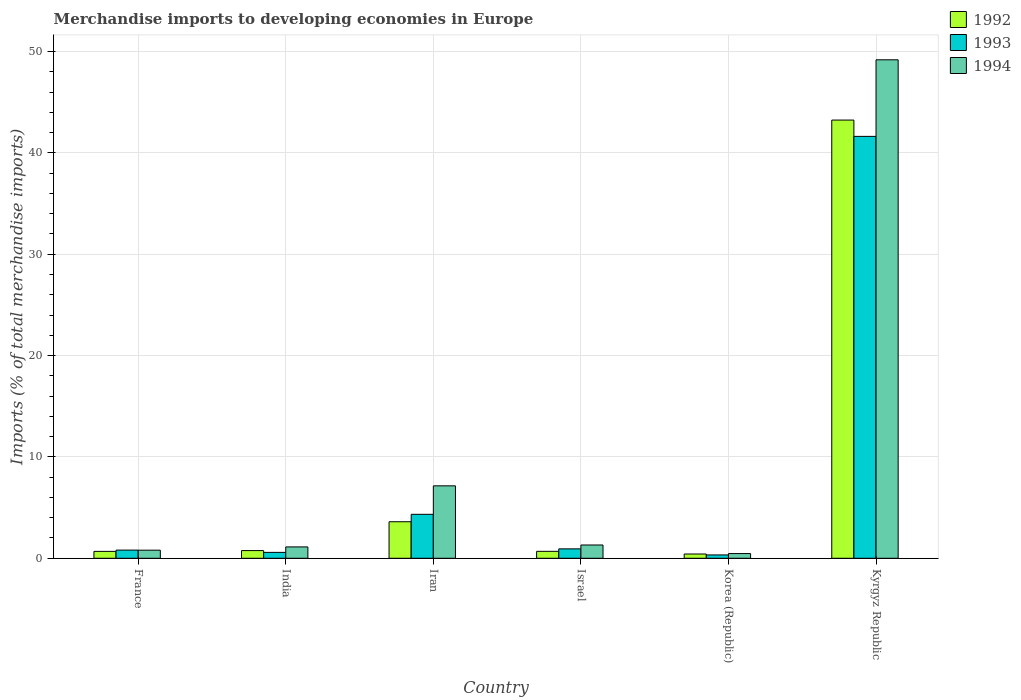How many groups of bars are there?
Offer a terse response. 6. Are the number of bars per tick equal to the number of legend labels?
Offer a very short reply. Yes. What is the label of the 3rd group of bars from the left?
Make the answer very short. Iran. In how many cases, is the number of bars for a given country not equal to the number of legend labels?
Provide a succinct answer. 0. What is the percentage total merchandise imports in 1994 in France?
Your answer should be compact. 0.8. Across all countries, what is the maximum percentage total merchandise imports in 1992?
Offer a terse response. 43.24. Across all countries, what is the minimum percentage total merchandise imports in 1993?
Provide a succinct answer. 0.33. In which country was the percentage total merchandise imports in 1992 maximum?
Offer a very short reply. Kyrgyz Republic. In which country was the percentage total merchandise imports in 1994 minimum?
Your answer should be very brief. Korea (Republic). What is the total percentage total merchandise imports in 1994 in the graph?
Offer a terse response. 60.02. What is the difference between the percentage total merchandise imports in 1994 in France and that in India?
Offer a very short reply. -0.32. What is the difference between the percentage total merchandise imports in 1992 in India and the percentage total merchandise imports in 1994 in Israel?
Provide a succinct answer. -0.55. What is the average percentage total merchandise imports in 1992 per country?
Your answer should be compact. 8.23. What is the difference between the percentage total merchandise imports of/in 1992 and percentage total merchandise imports of/in 1993 in Korea (Republic)?
Keep it short and to the point. 0.09. What is the ratio of the percentage total merchandise imports in 1992 in India to that in Israel?
Provide a short and direct response. 1.11. Is the percentage total merchandise imports in 1992 in France less than that in Israel?
Offer a terse response. Yes. Is the difference between the percentage total merchandise imports in 1992 in Israel and Kyrgyz Republic greater than the difference between the percentage total merchandise imports in 1993 in Israel and Kyrgyz Republic?
Offer a very short reply. No. What is the difference between the highest and the second highest percentage total merchandise imports in 1993?
Make the answer very short. -40.7. What is the difference between the highest and the lowest percentage total merchandise imports in 1992?
Your answer should be very brief. 42.82. In how many countries, is the percentage total merchandise imports in 1992 greater than the average percentage total merchandise imports in 1992 taken over all countries?
Ensure brevity in your answer.  1. What does the 2nd bar from the left in Iran represents?
Your response must be concise. 1993. How many bars are there?
Your response must be concise. 18. What is the difference between two consecutive major ticks on the Y-axis?
Provide a short and direct response. 10. Does the graph contain any zero values?
Ensure brevity in your answer.  No. Where does the legend appear in the graph?
Make the answer very short. Top right. What is the title of the graph?
Offer a very short reply. Merchandise imports to developing economies in Europe. What is the label or title of the Y-axis?
Offer a very short reply. Imports (% of total merchandise imports). What is the Imports (% of total merchandise imports) of 1992 in France?
Offer a terse response. 0.68. What is the Imports (% of total merchandise imports) in 1993 in France?
Offer a very short reply. 0.81. What is the Imports (% of total merchandise imports) of 1994 in France?
Your response must be concise. 0.8. What is the Imports (% of total merchandise imports) of 1992 in India?
Your answer should be very brief. 0.76. What is the Imports (% of total merchandise imports) in 1993 in India?
Provide a short and direct response. 0.58. What is the Imports (% of total merchandise imports) of 1994 in India?
Your response must be concise. 1.12. What is the Imports (% of total merchandise imports) of 1992 in Iran?
Offer a terse response. 3.6. What is the Imports (% of total merchandise imports) of 1993 in Iran?
Your answer should be compact. 4.34. What is the Imports (% of total merchandise imports) of 1994 in Iran?
Offer a very short reply. 7.15. What is the Imports (% of total merchandise imports) of 1992 in Israel?
Give a very brief answer. 0.68. What is the Imports (% of total merchandise imports) of 1993 in Israel?
Ensure brevity in your answer.  0.93. What is the Imports (% of total merchandise imports) of 1994 in Israel?
Make the answer very short. 1.31. What is the Imports (% of total merchandise imports) in 1992 in Korea (Republic)?
Offer a terse response. 0.42. What is the Imports (% of total merchandise imports) of 1993 in Korea (Republic)?
Ensure brevity in your answer.  0.33. What is the Imports (% of total merchandise imports) of 1994 in Korea (Republic)?
Offer a terse response. 0.46. What is the Imports (% of total merchandise imports) in 1992 in Kyrgyz Republic?
Give a very brief answer. 43.24. What is the Imports (% of total merchandise imports) of 1993 in Kyrgyz Republic?
Ensure brevity in your answer.  41.63. What is the Imports (% of total merchandise imports) of 1994 in Kyrgyz Republic?
Keep it short and to the point. 49.18. Across all countries, what is the maximum Imports (% of total merchandise imports) in 1992?
Provide a succinct answer. 43.24. Across all countries, what is the maximum Imports (% of total merchandise imports) of 1993?
Provide a succinct answer. 41.63. Across all countries, what is the maximum Imports (% of total merchandise imports) of 1994?
Provide a short and direct response. 49.18. Across all countries, what is the minimum Imports (% of total merchandise imports) of 1992?
Your answer should be very brief. 0.42. Across all countries, what is the minimum Imports (% of total merchandise imports) of 1993?
Your answer should be very brief. 0.33. Across all countries, what is the minimum Imports (% of total merchandise imports) of 1994?
Your answer should be compact. 0.46. What is the total Imports (% of total merchandise imports) of 1992 in the graph?
Keep it short and to the point. 49.38. What is the total Imports (% of total merchandise imports) in 1993 in the graph?
Offer a very short reply. 48.61. What is the total Imports (% of total merchandise imports) in 1994 in the graph?
Keep it short and to the point. 60.02. What is the difference between the Imports (% of total merchandise imports) in 1992 in France and that in India?
Offer a terse response. -0.08. What is the difference between the Imports (% of total merchandise imports) in 1993 in France and that in India?
Your answer should be compact. 0.22. What is the difference between the Imports (% of total merchandise imports) of 1994 in France and that in India?
Ensure brevity in your answer.  -0.32. What is the difference between the Imports (% of total merchandise imports) in 1992 in France and that in Iran?
Ensure brevity in your answer.  -2.92. What is the difference between the Imports (% of total merchandise imports) of 1993 in France and that in Iran?
Provide a short and direct response. -3.53. What is the difference between the Imports (% of total merchandise imports) in 1994 in France and that in Iran?
Your response must be concise. -6.35. What is the difference between the Imports (% of total merchandise imports) in 1992 in France and that in Israel?
Offer a very short reply. -0. What is the difference between the Imports (% of total merchandise imports) in 1993 in France and that in Israel?
Make the answer very short. -0.12. What is the difference between the Imports (% of total merchandise imports) in 1994 in France and that in Israel?
Your response must be concise. -0.51. What is the difference between the Imports (% of total merchandise imports) in 1992 in France and that in Korea (Republic)?
Provide a short and direct response. 0.26. What is the difference between the Imports (% of total merchandise imports) in 1993 in France and that in Korea (Republic)?
Your response must be concise. 0.48. What is the difference between the Imports (% of total merchandise imports) in 1994 in France and that in Korea (Republic)?
Ensure brevity in your answer.  0.34. What is the difference between the Imports (% of total merchandise imports) of 1992 in France and that in Kyrgyz Republic?
Offer a terse response. -42.56. What is the difference between the Imports (% of total merchandise imports) in 1993 in France and that in Kyrgyz Republic?
Make the answer very short. -40.82. What is the difference between the Imports (% of total merchandise imports) of 1994 in France and that in Kyrgyz Republic?
Your answer should be very brief. -48.38. What is the difference between the Imports (% of total merchandise imports) of 1992 in India and that in Iran?
Your answer should be compact. -2.84. What is the difference between the Imports (% of total merchandise imports) of 1993 in India and that in Iran?
Offer a terse response. -3.75. What is the difference between the Imports (% of total merchandise imports) of 1994 in India and that in Iran?
Keep it short and to the point. -6.03. What is the difference between the Imports (% of total merchandise imports) of 1992 in India and that in Israel?
Keep it short and to the point. 0.07. What is the difference between the Imports (% of total merchandise imports) in 1993 in India and that in Israel?
Give a very brief answer. -0.35. What is the difference between the Imports (% of total merchandise imports) of 1994 in India and that in Israel?
Your answer should be compact. -0.19. What is the difference between the Imports (% of total merchandise imports) in 1992 in India and that in Korea (Republic)?
Ensure brevity in your answer.  0.34. What is the difference between the Imports (% of total merchandise imports) of 1993 in India and that in Korea (Republic)?
Make the answer very short. 0.25. What is the difference between the Imports (% of total merchandise imports) of 1994 in India and that in Korea (Republic)?
Make the answer very short. 0.66. What is the difference between the Imports (% of total merchandise imports) in 1992 in India and that in Kyrgyz Republic?
Your response must be concise. -42.48. What is the difference between the Imports (% of total merchandise imports) in 1993 in India and that in Kyrgyz Republic?
Keep it short and to the point. -41.05. What is the difference between the Imports (% of total merchandise imports) of 1994 in India and that in Kyrgyz Republic?
Your answer should be compact. -48.06. What is the difference between the Imports (% of total merchandise imports) in 1992 in Iran and that in Israel?
Provide a short and direct response. 2.92. What is the difference between the Imports (% of total merchandise imports) of 1993 in Iran and that in Israel?
Offer a very short reply. 3.41. What is the difference between the Imports (% of total merchandise imports) in 1994 in Iran and that in Israel?
Provide a short and direct response. 5.84. What is the difference between the Imports (% of total merchandise imports) of 1992 in Iran and that in Korea (Republic)?
Ensure brevity in your answer.  3.18. What is the difference between the Imports (% of total merchandise imports) of 1993 in Iran and that in Korea (Republic)?
Your answer should be compact. 4.01. What is the difference between the Imports (% of total merchandise imports) of 1994 in Iran and that in Korea (Republic)?
Your response must be concise. 6.68. What is the difference between the Imports (% of total merchandise imports) in 1992 in Iran and that in Kyrgyz Republic?
Keep it short and to the point. -39.63. What is the difference between the Imports (% of total merchandise imports) in 1993 in Iran and that in Kyrgyz Republic?
Offer a terse response. -37.29. What is the difference between the Imports (% of total merchandise imports) in 1994 in Iran and that in Kyrgyz Republic?
Your response must be concise. -42.04. What is the difference between the Imports (% of total merchandise imports) in 1992 in Israel and that in Korea (Republic)?
Provide a short and direct response. 0.26. What is the difference between the Imports (% of total merchandise imports) in 1993 in Israel and that in Korea (Republic)?
Your response must be concise. 0.6. What is the difference between the Imports (% of total merchandise imports) in 1994 in Israel and that in Korea (Republic)?
Keep it short and to the point. 0.85. What is the difference between the Imports (% of total merchandise imports) in 1992 in Israel and that in Kyrgyz Republic?
Provide a succinct answer. -42.55. What is the difference between the Imports (% of total merchandise imports) in 1993 in Israel and that in Kyrgyz Republic?
Make the answer very short. -40.7. What is the difference between the Imports (% of total merchandise imports) in 1994 in Israel and that in Kyrgyz Republic?
Your response must be concise. -47.87. What is the difference between the Imports (% of total merchandise imports) of 1992 in Korea (Republic) and that in Kyrgyz Republic?
Ensure brevity in your answer.  -42.82. What is the difference between the Imports (% of total merchandise imports) of 1993 in Korea (Republic) and that in Kyrgyz Republic?
Offer a very short reply. -41.3. What is the difference between the Imports (% of total merchandise imports) of 1994 in Korea (Republic) and that in Kyrgyz Republic?
Ensure brevity in your answer.  -48.72. What is the difference between the Imports (% of total merchandise imports) of 1992 in France and the Imports (% of total merchandise imports) of 1993 in India?
Keep it short and to the point. 0.1. What is the difference between the Imports (% of total merchandise imports) in 1992 in France and the Imports (% of total merchandise imports) in 1994 in India?
Make the answer very short. -0.44. What is the difference between the Imports (% of total merchandise imports) in 1993 in France and the Imports (% of total merchandise imports) in 1994 in India?
Make the answer very short. -0.31. What is the difference between the Imports (% of total merchandise imports) of 1992 in France and the Imports (% of total merchandise imports) of 1993 in Iran?
Your answer should be compact. -3.66. What is the difference between the Imports (% of total merchandise imports) in 1992 in France and the Imports (% of total merchandise imports) in 1994 in Iran?
Make the answer very short. -6.47. What is the difference between the Imports (% of total merchandise imports) in 1993 in France and the Imports (% of total merchandise imports) in 1994 in Iran?
Give a very brief answer. -6.34. What is the difference between the Imports (% of total merchandise imports) of 1992 in France and the Imports (% of total merchandise imports) of 1993 in Israel?
Provide a short and direct response. -0.25. What is the difference between the Imports (% of total merchandise imports) in 1992 in France and the Imports (% of total merchandise imports) in 1994 in Israel?
Provide a succinct answer. -0.63. What is the difference between the Imports (% of total merchandise imports) of 1993 in France and the Imports (% of total merchandise imports) of 1994 in Israel?
Provide a succinct answer. -0.5. What is the difference between the Imports (% of total merchandise imports) of 1992 in France and the Imports (% of total merchandise imports) of 1993 in Korea (Republic)?
Offer a terse response. 0.35. What is the difference between the Imports (% of total merchandise imports) in 1992 in France and the Imports (% of total merchandise imports) in 1994 in Korea (Republic)?
Your response must be concise. 0.22. What is the difference between the Imports (% of total merchandise imports) in 1993 in France and the Imports (% of total merchandise imports) in 1994 in Korea (Republic)?
Your response must be concise. 0.34. What is the difference between the Imports (% of total merchandise imports) in 1992 in France and the Imports (% of total merchandise imports) in 1993 in Kyrgyz Republic?
Your response must be concise. -40.95. What is the difference between the Imports (% of total merchandise imports) of 1992 in France and the Imports (% of total merchandise imports) of 1994 in Kyrgyz Republic?
Provide a short and direct response. -48.5. What is the difference between the Imports (% of total merchandise imports) of 1993 in France and the Imports (% of total merchandise imports) of 1994 in Kyrgyz Republic?
Ensure brevity in your answer.  -48.38. What is the difference between the Imports (% of total merchandise imports) in 1992 in India and the Imports (% of total merchandise imports) in 1993 in Iran?
Provide a short and direct response. -3.58. What is the difference between the Imports (% of total merchandise imports) of 1992 in India and the Imports (% of total merchandise imports) of 1994 in Iran?
Ensure brevity in your answer.  -6.39. What is the difference between the Imports (% of total merchandise imports) of 1993 in India and the Imports (% of total merchandise imports) of 1994 in Iran?
Keep it short and to the point. -6.57. What is the difference between the Imports (% of total merchandise imports) of 1992 in India and the Imports (% of total merchandise imports) of 1993 in Israel?
Make the answer very short. -0.17. What is the difference between the Imports (% of total merchandise imports) in 1992 in India and the Imports (% of total merchandise imports) in 1994 in Israel?
Make the answer very short. -0.55. What is the difference between the Imports (% of total merchandise imports) of 1993 in India and the Imports (% of total merchandise imports) of 1994 in Israel?
Offer a very short reply. -0.73. What is the difference between the Imports (% of total merchandise imports) in 1992 in India and the Imports (% of total merchandise imports) in 1993 in Korea (Republic)?
Offer a terse response. 0.43. What is the difference between the Imports (% of total merchandise imports) in 1992 in India and the Imports (% of total merchandise imports) in 1994 in Korea (Republic)?
Give a very brief answer. 0.3. What is the difference between the Imports (% of total merchandise imports) of 1993 in India and the Imports (% of total merchandise imports) of 1994 in Korea (Republic)?
Ensure brevity in your answer.  0.12. What is the difference between the Imports (% of total merchandise imports) in 1992 in India and the Imports (% of total merchandise imports) in 1993 in Kyrgyz Republic?
Your response must be concise. -40.87. What is the difference between the Imports (% of total merchandise imports) of 1992 in India and the Imports (% of total merchandise imports) of 1994 in Kyrgyz Republic?
Ensure brevity in your answer.  -48.42. What is the difference between the Imports (% of total merchandise imports) of 1993 in India and the Imports (% of total merchandise imports) of 1994 in Kyrgyz Republic?
Your response must be concise. -48.6. What is the difference between the Imports (% of total merchandise imports) in 1992 in Iran and the Imports (% of total merchandise imports) in 1993 in Israel?
Make the answer very short. 2.68. What is the difference between the Imports (% of total merchandise imports) of 1992 in Iran and the Imports (% of total merchandise imports) of 1994 in Israel?
Your answer should be very brief. 2.29. What is the difference between the Imports (% of total merchandise imports) of 1993 in Iran and the Imports (% of total merchandise imports) of 1994 in Israel?
Your answer should be very brief. 3.03. What is the difference between the Imports (% of total merchandise imports) in 1992 in Iran and the Imports (% of total merchandise imports) in 1993 in Korea (Republic)?
Keep it short and to the point. 3.27. What is the difference between the Imports (% of total merchandise imports) in 1992 in Iran and the Imports (% of total merchandise imports) in 1994 in Korea (Republic)?
Offer a very short reply. 3.14. What is the difference between the Imports (% of total merchandise imports) in 1993 in Iran and the Imports (% of total merchandise imports) in 1994 in Korea (Republic)?
Provide a short and direct response. 3.87. What is the difference between the Imports (% of total merchandise imports) of 1992 in Iran and the Imports (% of total merchandise imports) of 1993 in Kyrgyz Republic?
Give a very brief answer. -38.02. What is the difference between the Imports (% of total merchandise imports) in 1992 in Iran and the Imports (% of total merchandise imports) in 1994 in Kyrgyz Republic?
Offer a very short reply. -45.58. What is the difference between the Imports (% of total merchandise imports) of 1993 in Iran and the Imports (% of total merchandise imports) of 1994 in Kyrgyz Republic?
Make the answer very short. -44.85. What is the difference between the Imports (% of total merchandise imports) of 1992 in Israel and the Imports (% of total merchandise imports) of 1993 in Korea (Republic)?
Keep it short and to the point. 0.35. What is the difference between the Imports (% of total merchandise imports) of 1992 in Israel and the Imports (% of total merchandise imports) of 1994 in Korea (Republic)?
Provide a short and direct response. 0.22. What is the difference between the Imports (% of total merchandise imports) of 1993 in Israel and the Imports (% of total merchandise imports) of 1994 in Korea (Republic)?
Make the answer very short. 0.46. What is the difference between the Imports (% of total merchandise imports) in 1992 in Israel and the Imports (% of total merchandise imports) in 1993 in Kyrgyz Republic?
Ensure brevity in your answer.  -40.94. What is the difference between the Imports (% of total merchandise imports) of 1992 in Israel and the Imports (% of total merchandise imports) of 1994 in Kyrgyz Republic?
Ensure brevity in your answer.  -48.5. What is the difference between the Imports (% of total merchandise imports) in 1993 in Israel and the Imports (% of total merchandise imports) in 1994 in Kyrgyz Republic?
Make the answer very short. -48.26. What is the difference between the Imports (% of total merchandise imports) in 1992 in Korea (Republic) and the Imports (% of total merchandise imports) in 1993 in Kyrgyz Republic?
Offer a very short reply. -41.21. What is the difference between the Imports (% of total merchandise imports) of 1992 in Korea (Republic) and the Imports (% of total merchandise imports) of 1994 in Kyrgyz Republic?
Make the answer very short. -48.76. What is the difference between the Imports (% of total merchandise imports) in 1993 in Korea (Republic) and the Imports (% of total merchandise imports) in 1994 in Kyrgyz Republic?
Provide a succinct answer. -48.85. What is the average Imports (% of total merchandise imports) in 1992 per country?
Provide a short and direct response. 8.23. What is the average Imports (% of total merchandise imports) in 1993 per country?
Offer a very short reply. 8.1. What is the average Imports (% of total merchandise imports) of 1994 per country?
Provide a short and direct response. 10. What is the difference between the Imports (% of total merchandise imports) of 1992 and Imports (% of total merchandise imports) of 1993 in France?
Offer a very short reply. -0.13. What is the difference between the Imports (% of total merchandise imports) in 1992 and Imports (% of total merchandise imports) in 1994 in France?
Your answer should be very brief. -0.12. What is the difference between the Imports (% of total merchandise imports) of 1993 and Imports (% of total merchandise imports) of 1994 in France?
Provide a short and direct response. 0.01. What is the difference between the Imports (% of total merchandise imports) of 1992 and Imports (% of total merchandise imports) of 1993 in India?
Give a very brief answer. 0.18. What is the difference between the Imports (% of total merchandise imports) of 1992 and Imports (% of total merchandise imports) of 1994 in India?
Your answer should be very brief. -0.36. What is the difference between the Imports (% of total merchandise imports) in 1993 and Imports (% of total merchandise imports) in 1994 in India?
Your answer should be very brief. -0.54. What is the difference between the Imports (% of total merchandise imports) of 1992 and Imports (% of total merchandise imports) of 1993 in Iran?
Provide a short and direct response. -0.73. What is the difference between the Imports (% of total merchandise imports) of 1992 and Imports (% of total merchandise imports) of 1994 in Iran?
Your answer should be very brief. -3.54. What is the difference between the Imports (% of total merchandise imports) in 1993 and Imports (% of total merchandise imports) in 1994 in Iran?
Provide a short and direct response. -2.81. What is the difference between the Imports (% of total merchandise imports) of 1992 and Imports (% of total merchandise imports) of 1993 in Israel?
Your answer should be very brief. -0.24. What is the difference between the Imports (% of total merchandise imports) in 1992 and Imports (% of total merchandise imports) in 1994 in Israel?
Offer a terse response. -0.62. What is the difference between the Imports (% of total merchandise imports) in 1993 and Imports (% of total merchandise imports) in 1994 in Israel?
Ensure brevity in your answer.  -0.38. What is the difference between the Imports (% of total merchandise imports) in 1992 and Imports (% of total merchandise imports) in 1993 in Korea (Republic)?
Keep it short and to the point. 0.09. What is the difference between the Imports (% of total merchandise imports) of 1992 and Imports (% of total merchandise imports) of 1994 in Korea (Republic)?
Give a very brief answer. -0.04. What is the difference between the Imports (% of total merchandise imports) of 1993 and Imports (% of total merchandise imports) of 1994 in Korea (Republic)?
Ensure brevity in your answer.  -0.13. What is the difference between the Imports (% of total merchandise imports) of 1992 and Imports (% of total merchandise imports) of 1993 in Kyrgyz Republic?
Keep it short and to the point. 1.61. What is the difference between the Imports (% of total merchandise imports) in 1992 and Imports (% of total merchandise imports) in 1994 in Kyrgyz Republic?
Make the answer very short. -5.95. What is the difference between the Imports (% of total merchandise imports) of 1993 and Imports (% of total merchandise imports) of 1994 in Kyrgyz Republic?
Provide a short and direct response. -7.56. What is the ratio of the Imports (% of total merchandise imports) in 1992 in France to that in India?
Keep it short and to the point. 0.9. What is the ratio of the Imports (% of total merchandise imports) of 1993 in France to that in India?
Provide a succinct answer. 1.39. What is the ratio of the Imports (% of total merchandise imports) in 1994 in France to that in India?
Make the answer very short. 0.71. What is the ratio of the Imports (% of total merchandise imports) in 1992 in France to that in Iran?
Ensure brevity in your answer.  0.19. What is the ratio of the Imports (% of total merchandise imports) in 1993 in France to that in Iran?
Provide a succinct answer. 0.19. What is the ratio of the Imports (% of total merchandise imports) of 1994 in France to that in Iran?
Provide a short and direct response. 0.11. What is the ratio of the Imports (% of total merchandise imports) in 1993 in France to that in Israel?
Offer a terse response. 0.87. What is the ratio of the Imports (% of total merchandise imports) in 1994 in France to that in Israel?
Ensure brevity in your answer.  0.61. What is the ratio of the Imports (% of total merchandise imports) of 1992 in France to that in Korea (Republic)?
Give a very brief answer. 1.61. What is the ratio of the Imports (% of total merchandise imports) in 1993 in France to that in Korea (Republic)?
Your response must be concise. 2.45. What is the ratio of the Imports (% of total merchandise imports) of 1994 in France to that in Korea (Republic)?
Your response must be concise. 1.72. What is the ratio of the Imports (% of total merchandise imports) in 1992 in France to that in Kyrgyz Republic?
Your answer should be very brief. 0.02. What is the ratio of the Imports (% of total merchandise imports) in 1993 in France to that in Kyrgyz Republic?
Provide a short and direct response. 0.02. What is the ratio of the Imports (% of total merchandise imports) in 1994 in France to that in Kyrgyz Republic?
Your answer should be compact. 0.02. What is the ratio of the Imports (% of total merchandise imports) in 1992 in India to that in Iran?
Your answer should be compact. 0.21. What is the ratio of the Imports (% of total merchandise imports) of 1993 in India to that in Iran?
Your answer should be compact. 0.13. What is the ratio of the Imports (% of total merchandise imports) in 1994 in India to that in Iran?
Ensure brevity in your answer.  0.16. What is the ratio of the Imports (% of total merchandise imports) in 1992 in India to that in Israel?
Your answer should be very brief. 1.11. What is the ratio of the Imports (% of total merchandise imports) of 1993 in India to that in Israel?
Keep it short and to the point. 0.63. What is the ratio of the Imports (% of total merchandise imports) in 1994 in India to that in Israel?
Ensure brevity in your answer.  0.86. What is the ratio of the Imports (% of total merchandise imports) of 1992 in India to that in Korea (Republic)?
Provide a succinct answer. 1.8. What is the ratio of the Imports (% of total merchandise imports) of 1993 in India to that in Korea (Republic)?
Keep it short and to the point. 1.76. What is the ratio of the Imports (% of total merchandise imports) of 1994 in India to that in Korea (Republic)?
Offer a very short reply. 2.42. What is the ratio of the Imports (% of total merchandise imports) in 1992 in India to that in Kyrgyz Republic?
Offer a very short reply. 0.02. What is the ratio of the Imports (% of total merchandise imports) in 1993 in India to that in Kyrgyz Republic?
Give a very brief answer. 0.01. What is the ratio of the Imports (% of total merchandise imports) of 1994 in India to that in Kyrgyz Republic?
Offer a terse response. 0.02. What is the ratio of the Imports (% of total merchandise imports) of 1992 in Iran to that in Israel?
Offer a terse response. 5.26. What is the ratio of the Imports (% of total merchandise imports) of 1993 in Iran to that in Israel?
Make the answer very short. 4.68. What is the ratio of the Imports (% of total merchandise imports) in 1994 in Iran to that in Israel?
Ensure brevity in your answer.  5.46. What is the ratio of the Imports (% of total merchandise imports) of 1992 in Iran to that in Korea (Republic)?
Make the answer very short. 8.56. What is the ratio of the Imports (% of total merchandise imports) in 1993 in Iran to that in Korea (Republic)?
Make the answer very short. 13.15. What is the ratio of the Imports (% of total merchandise imports) in 1994 in Iran to that in Korea (Republic)?
Make the answer very short. 15.43. What is the ratio of the Imports (% of total merchandise imports) in 1992 in Iran to that in Kyrgyz Republic?
Make the answer very short. 0.08. What is the ratio of the Imports (% of total merchandise imports) in 1993 in Iran to that in Kyrgyz Republic?
Provide a succinct answer. 0.1. What is the ratio of the Imports (% of total merchandise imports) in 1994 in Iran to that in Kyrgyz Republic?
Offer a very short reply. 0.15. What is the ratio of the Imports (% of total merchandise imports) in 1992 in Israel to that in Korea (Republic)?
Keep it short and to the point. 1.63. What is the ratio of the Imports (% of total merchandise imports) of 1993 in Israel to that in Korea (Republic)?
Your response must be concise. 2.81. What is the ratio of the Imports (% of total merchandise imports) in 1994 in Israel to that in Korea (Republic)?
Your response must be concise. 2.83. What is the ratio of the Imports (% of total merchandise imports) in 1992 in Israel to that in Kyrgyz Republic?
Provide a succinct answer. 0.02. What is the ratio of the Imports (% of total merchandise imports) of 1993 in Israel to that in Kyrgyz Republic?
Offer a terse response. 0.02. What is the ratio of the Imports (% of total merchandise imports) in 1994 in Israel to that in Kyrgyz Republic?
Provide a short and direct response. 0.03. What is the ratio of the Imports (% of total merchandise imports) in 1992 in Korea (Republic) to that in Kyrgyz Republic?
Your response must be concise. 0.01. What is the ratio of the Imports (% of total merchandise imports) of 1993 in Korea (Republic) to that in Kyrgyz Republic?
Give a very brief answer. 0.01. What is the ratio of the Imports (% of total merchandise imports) in 1994 in Korea (Republic) to that in Kyrgyz Republic?
Offer a very short reply. 0.01. What is the difference between the highest and the second highest Imports (% of total merchandise imports) in 1992?
Provide a succinct answer. 39.63. What is the difference between the highest and the second highest Imports (% of total merchandise imports) in 1993?
Your response must be concise. 37.29. What is the difference between the highest and the second highest Imports (% of total merchandise imports) of 1994?
Give a very brief answer. 42.04. What is the difference between the highest and the lowest Imports (% of total merchandise imports) in 1992?
Your response must be concise. 42.82. What is the difference between the highest and the lowest Imports (% of total merchandise imports) of 1993?
Provide a succinct answer. 41.3. What is the difference between the highest and the lowest Imports (% of total merchandise imports) in 1994?
Ensure brevity in your answer.  48.72. 